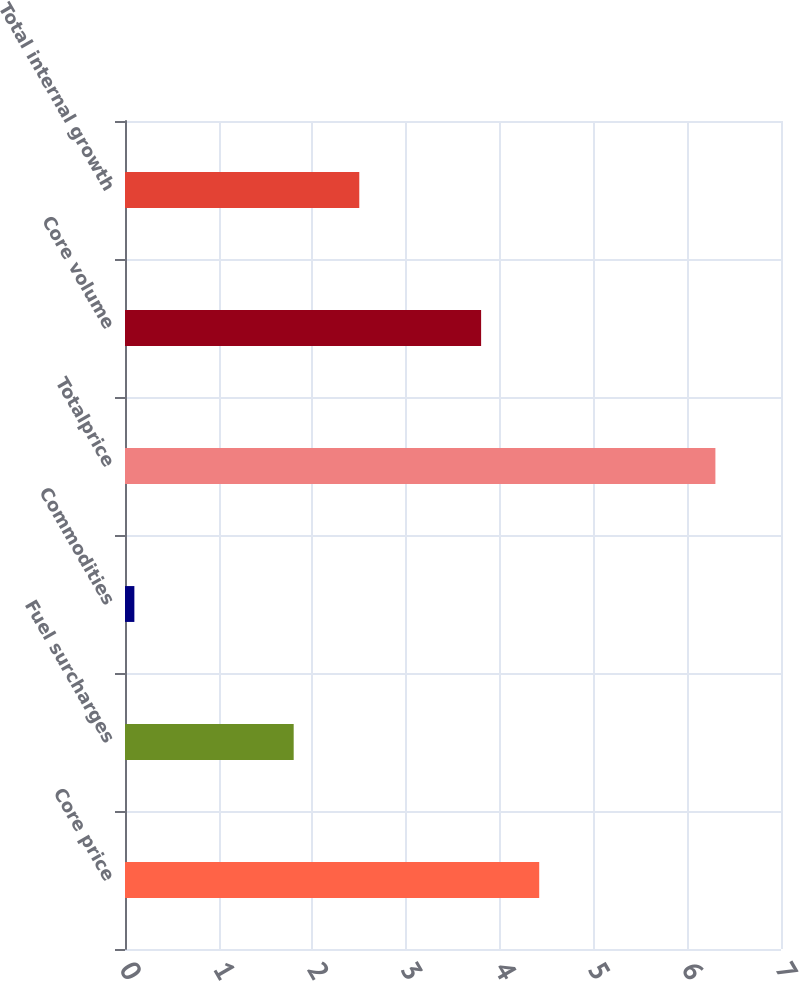<chart> <loc_0><loc_0><loc_500><loc_500><bar_chart><fcel>Core price<fcel>Fuel surcharges<fcel>Commodities<fcel>Totalprice<fcel>Core volume<fcel>Total internal growth<nl><fcel>4.42<fcel>1.8<fcel>0.1<fcel>6.3<fcel>3.8<fcel>2.5<nl></chart> 